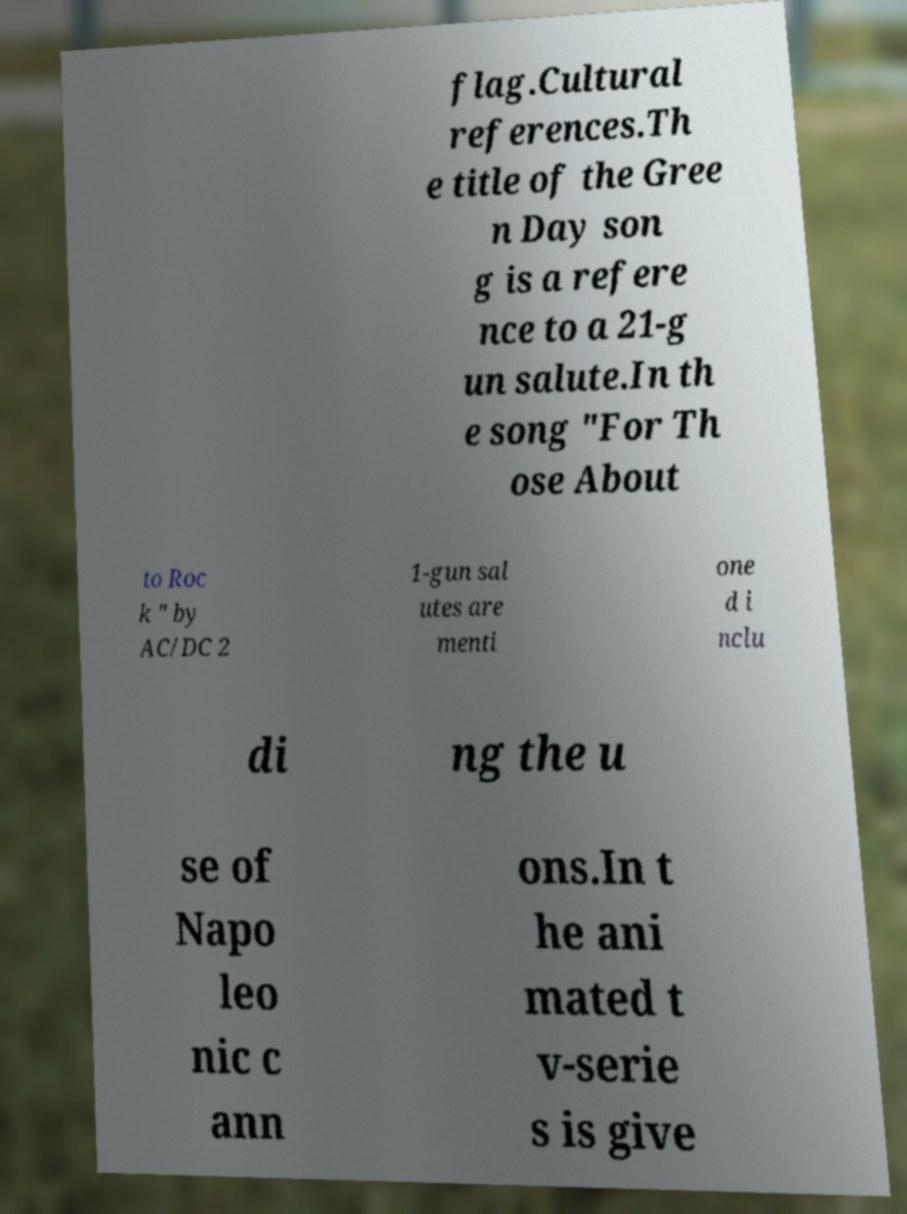Could you extract and type out the text from this image? flag.Cultural references.Th e title of the Gree n Day son g is a refere nce to a 21-g un salute.In th e song "For Th ose About to Roc k " by AC/DC 2 1-gun sal utes are menti one d i nclu di ng the u se of Napo leo nic c ann ons.In t he ani mated t v-serie s is give 